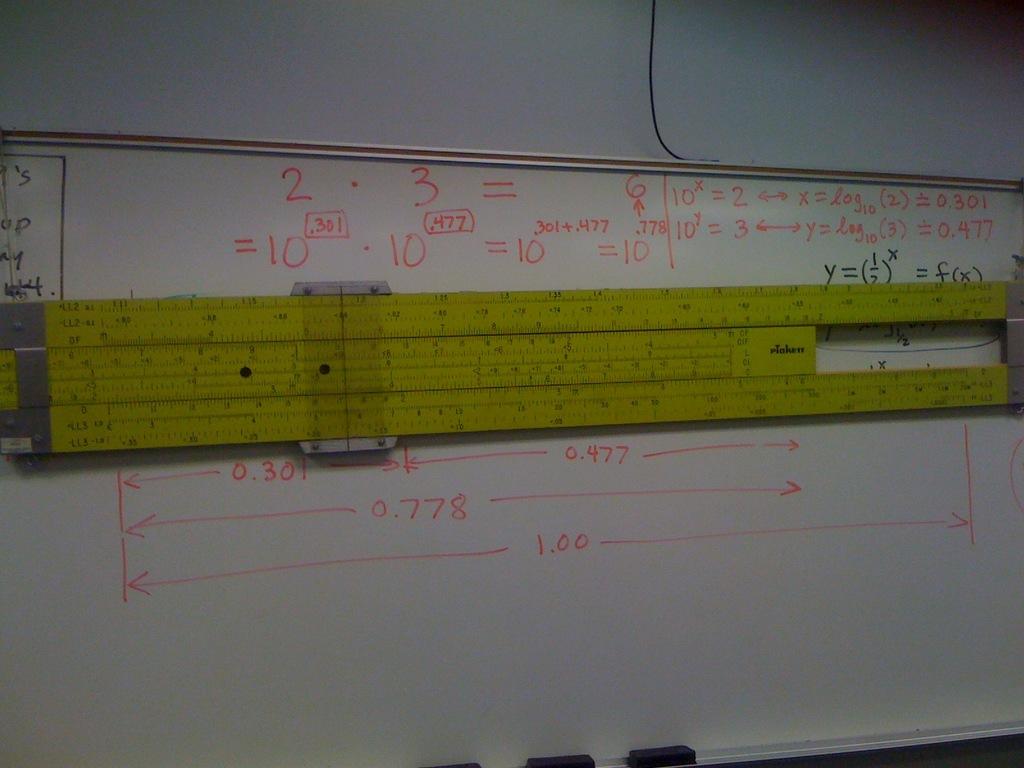What is the length shown on the bottom line?
Your response must be concise. 1.00. What is the length shown on the middle line?
Keep it short and to the point. 0.778. 